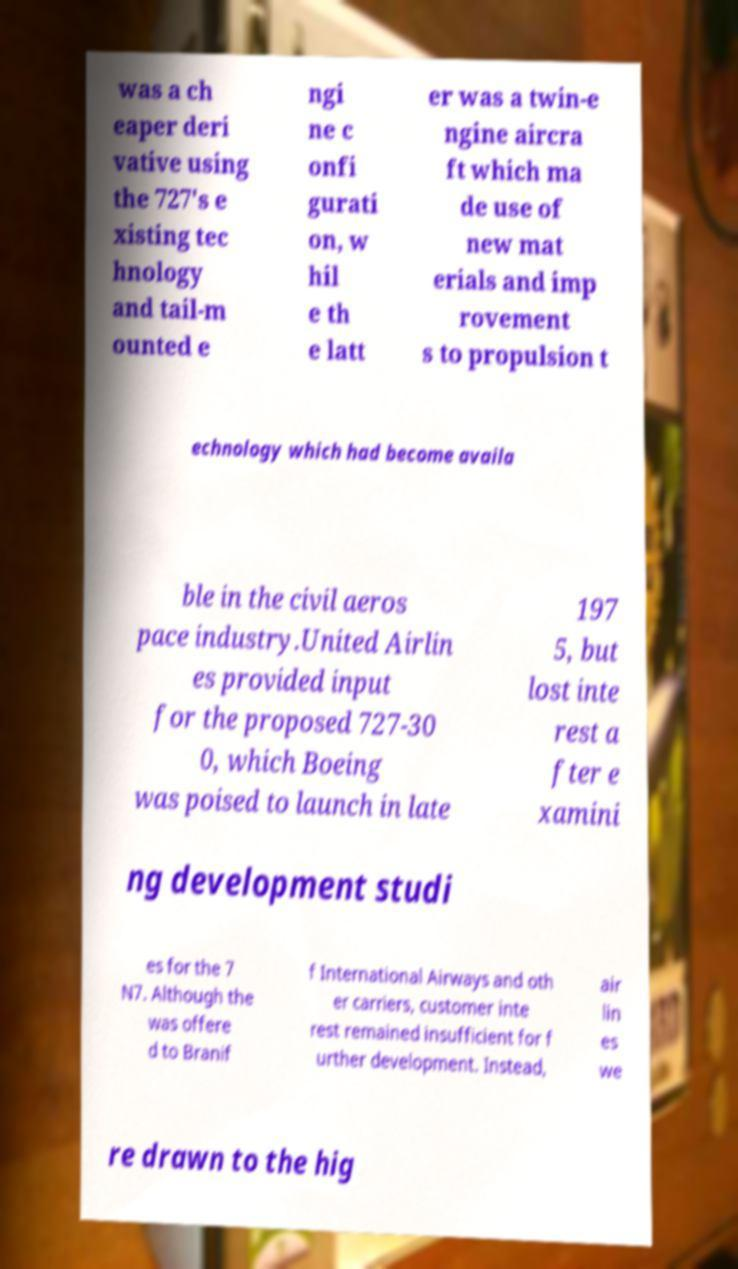What messages or text are displayed in this image? I need them in a readable, typed format. was a ch eaper deri vative using the 727's e xisting tec hnology and tail-m ounted e ngi ne c onfi gurati on, w hil e th e latt er was a twin-e ngine aircra ft which ma de use of new mat erials and imp rovement s to propulsion t echnology which had become availa ble in the civil aeros pace industry.United Airlin es provided input for the proposed 727-30 0, which Boeing was poised to launch in late 197 5, but lost inte rest a fter e xamini ng development studi es for the 7 N7. Although the was offere d to Branif f International Airways and oth er carriers, customer inte rest remained insufficient for f urther development. Instead, air lin es we re drawn to the hig 